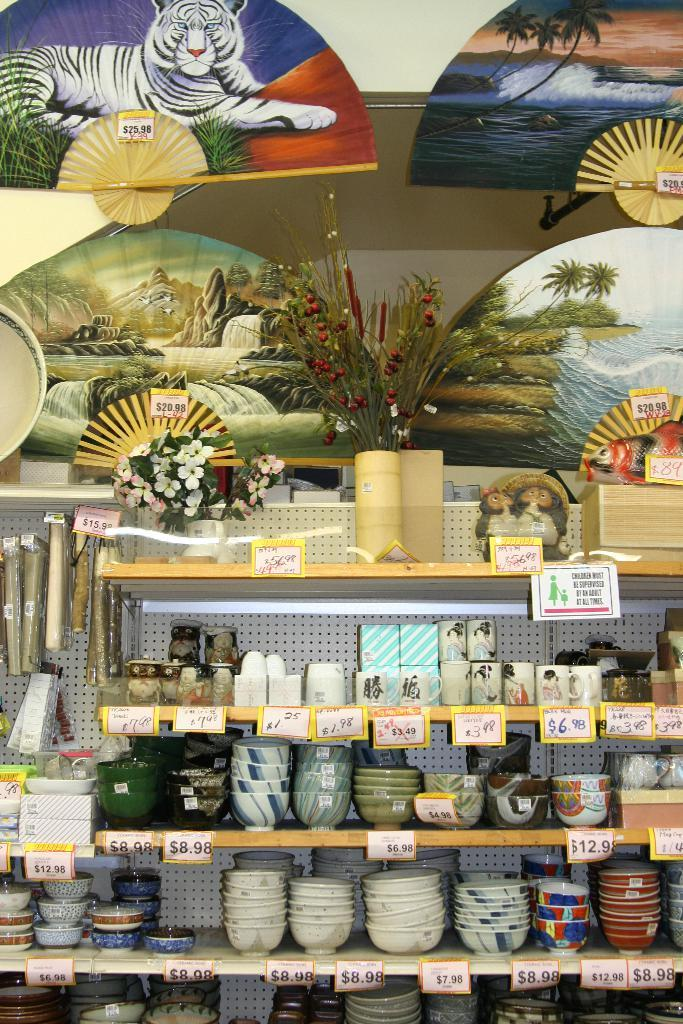What types of containers are visible in the image? There are bowls, cups, and boxes in the image. Are there any indications of the items' prices in the image? Yes, price tags are present in the image. What decorative elements can be seen in the image? Flowers are visible in the image. How are the items arranged in the image? The items are placed in racks. What can be seen in the background of the image? There is a wall in the background of the image. What type of ice can be seen melting in the image? There is no ice present in the image; it features bowls, cups, boxes, price tags, flowers, and racks. How do people say good-bye to each other in the image? There is no interaction between people in the image, so it is not possible to determine how they might say good-bye to each other. 